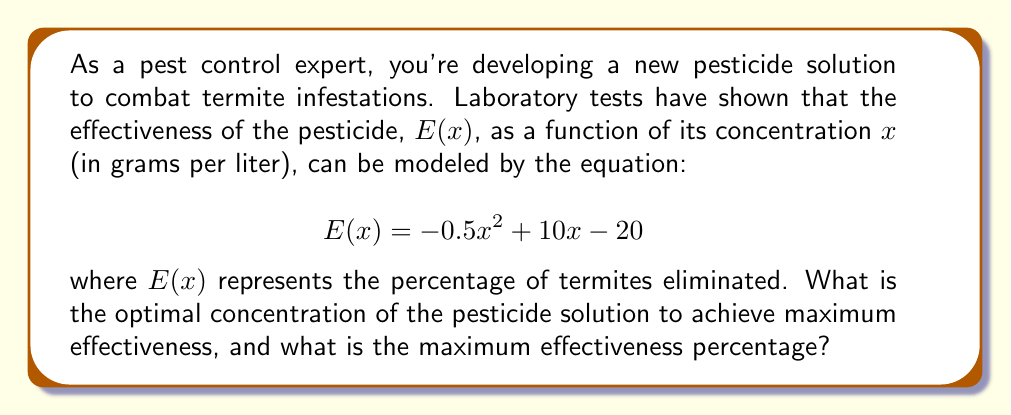Solve this math problem. To solve this optimization problem, we need to follow these steps:

1) The function $E(x) = -0.5x^2 + 10x - 20$ is a quadratic function, and its graph is a parabola that opens downward (because the coefficient of $x^2$ is negative).

2) The maximum point of a parabola occurs at the vertex. For a quadratic function in the form $f(x) = ax^2 + bx + c$, the x-coordinate of the vertex is given by $x = -\frac{b}{2a}$.

3) In our case, $a = -0.5$, $b = 10$, and $c = -20$. Let's call the optimal concentration $x^*$:

   $$x^* = -\frac{b}{2a} = -\frac{10}{2(-0.5)} = -\frac{10}{-1} = 10$$

4) To find the maximum effectiveness, we substitute $x^* = 10$ into the original function:

   $$E(10) = -0.5(10)^2 + 10(10) - 20$$
   $$= -0.5(100) + 100 - 20$$
   $$= -50 + 100 - 20$$
   $$= 30$$

5) Therefore, the maximum effectiveness is 30%.
Answer: The optimal concentration of the pesticide solution is 10 grams per liter, and the maximum effectiveness is 30%. 